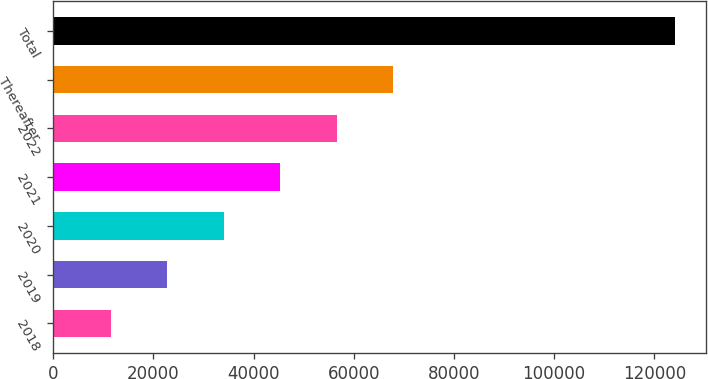Convert chart to OTSL. <chart><loc_0><loc_0><loc_500><loc_500><bar_chart><fcel>2018<fcel>2019<fcel>2020<fcel>2021<fcel>2022<fcel>Thereafter<fcel>Total<nl><fcel>11500<fcel>22763<fcel>34026<fcel>45289<fcel>56552<fcel>67815<fcel>124130<nl></chart> 